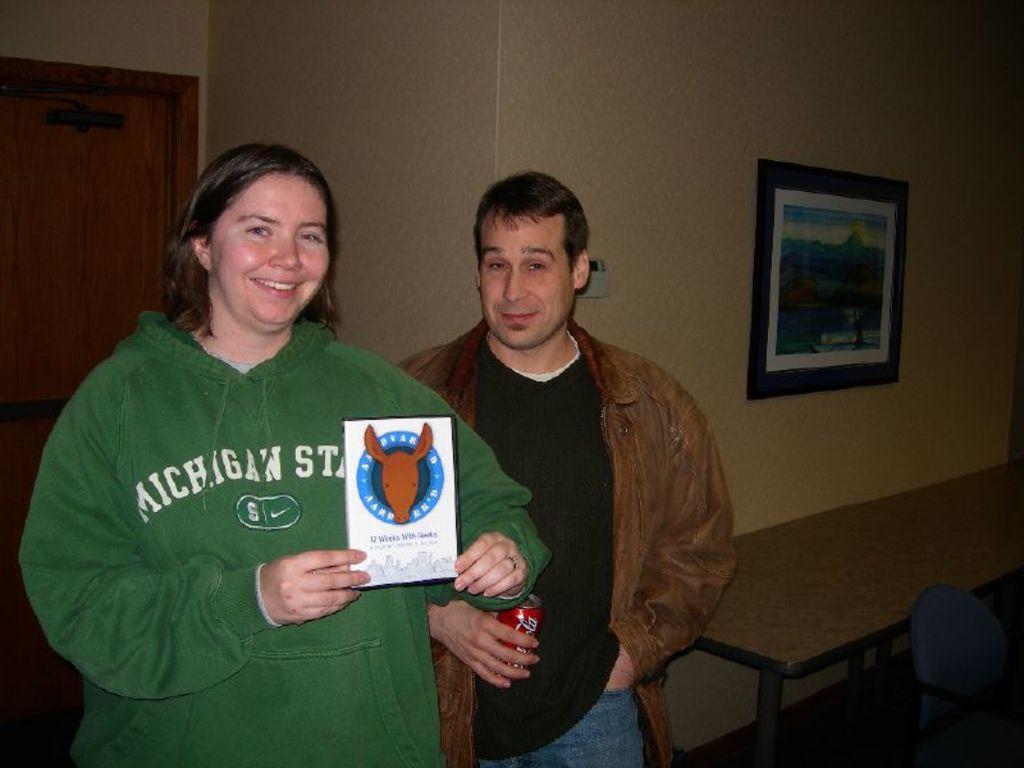Describe this image in one or two sentences. There is a woman standing and holding a book as we can see on the left side of this image. There is one man standing in the middle of this image is holding a coke. We can see a wall in the background. There is a door on the left side of this image and there is a frame attached to the wall. There is a table and a chair in the bottom right corner of this image. 